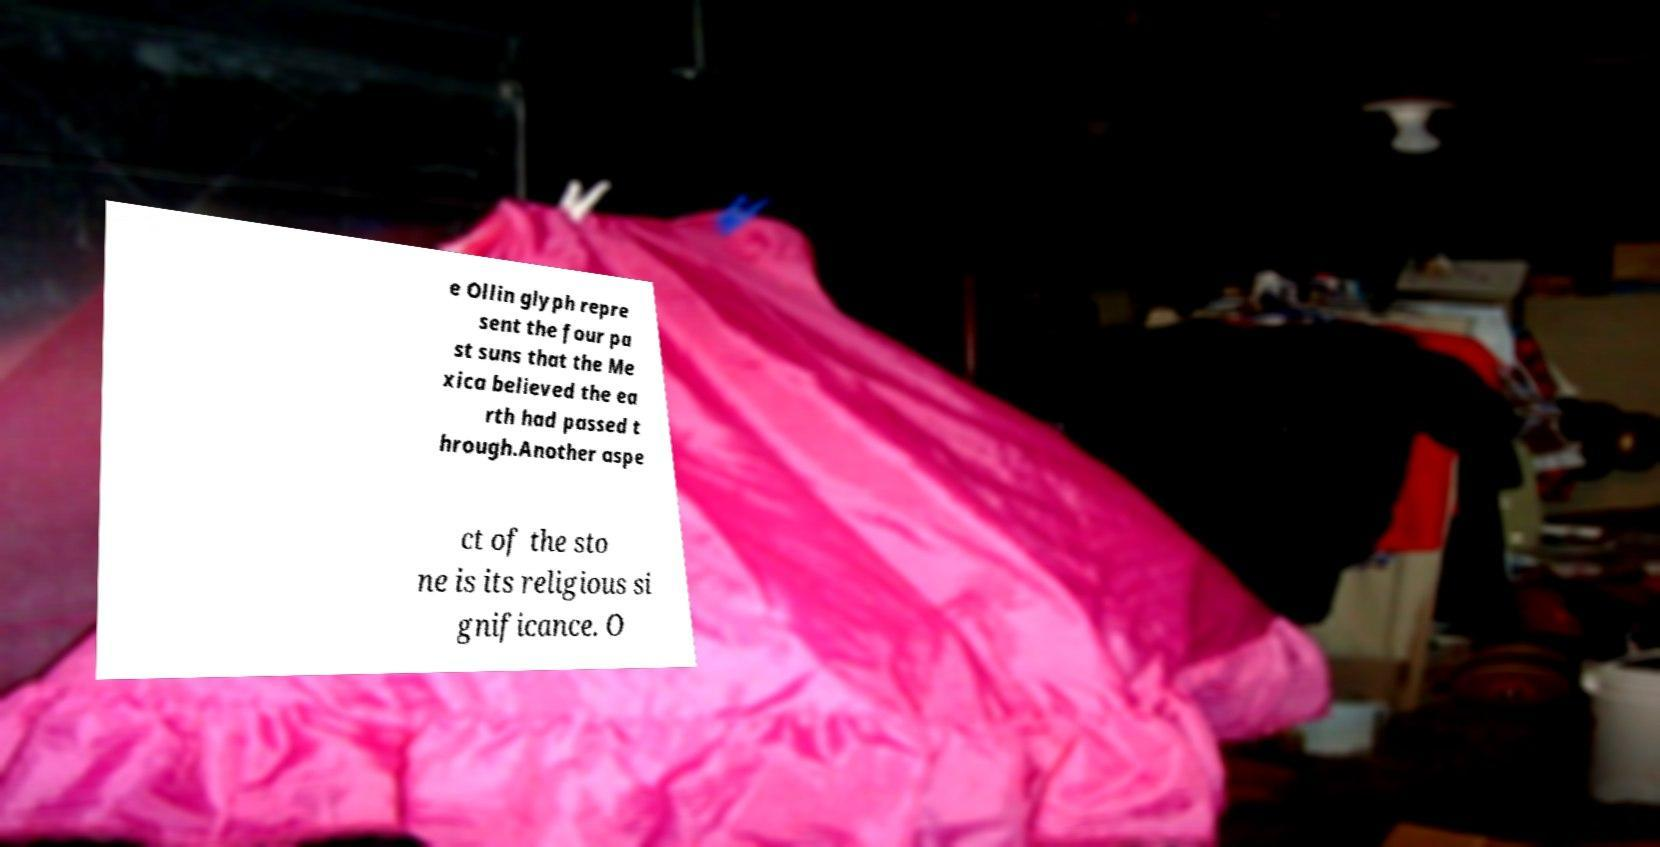There's text embedded in this image that I need extracted. Can you transcribe it verbatim? e Ollin glyph repre sent the four pa st suns that the Me xica believed the ea rth had passed t hrough.Another aspe ct of the sto ne is its religious si gnificance. O 